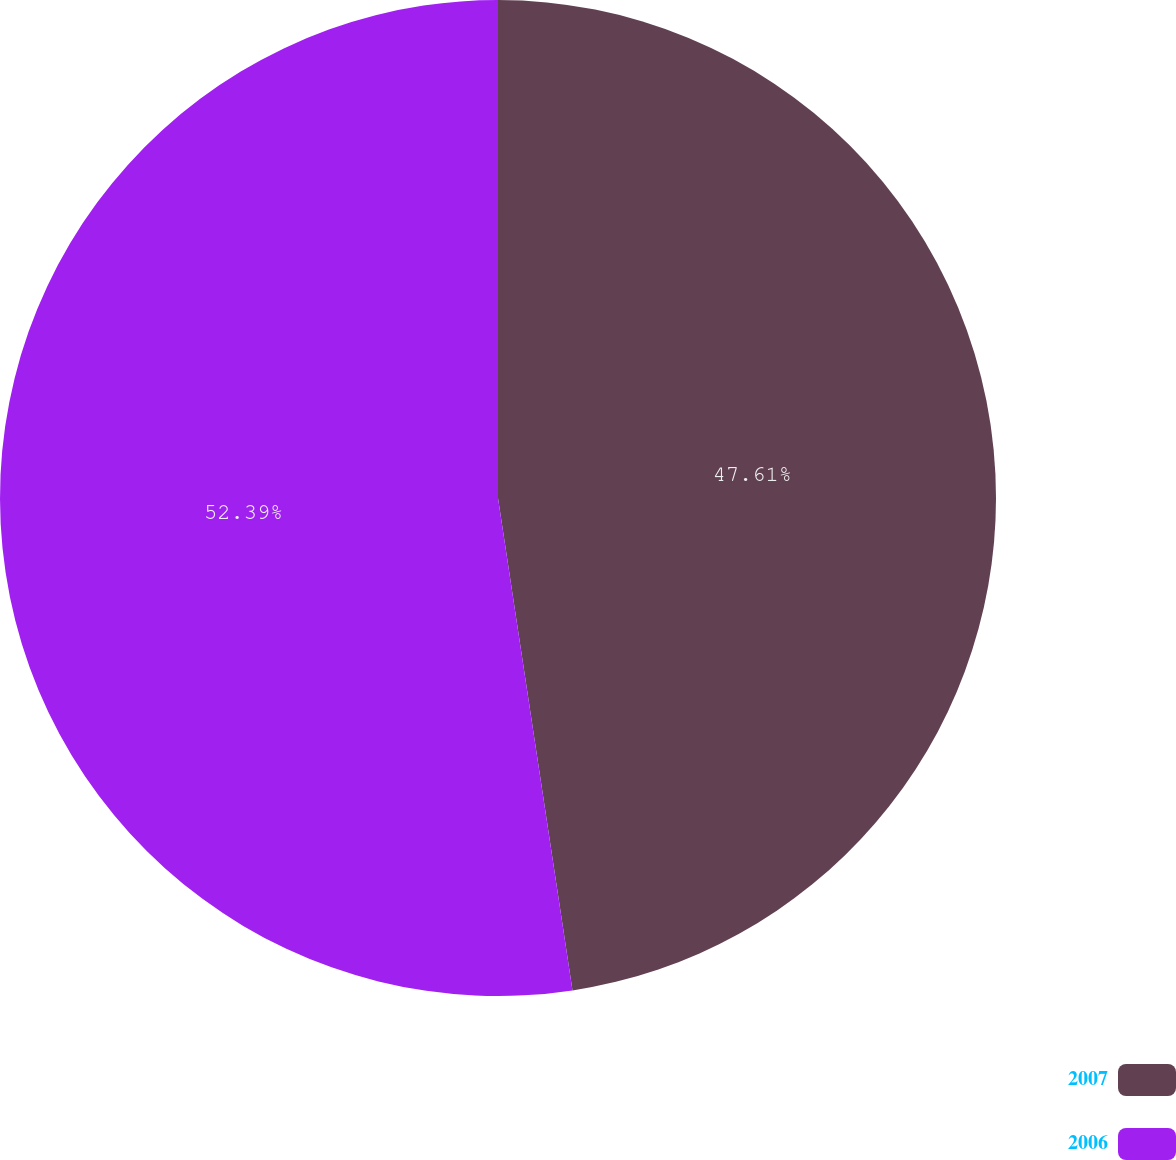<chart> <loc_0><loc_0><loc_500><loc_500><pie_chart><fcel>2007<fcel>2006<nl><fcel>47.61%<fcel>52.39%<nl></chart> 